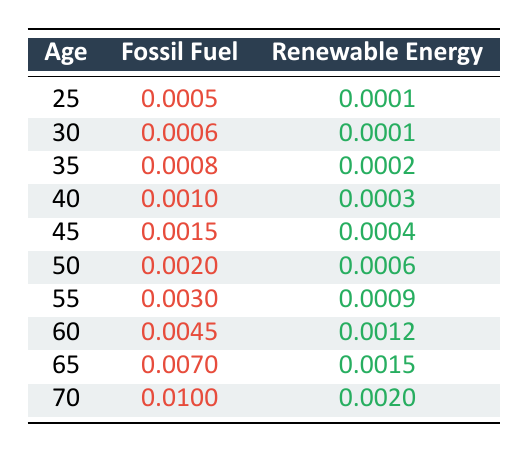What is the Fossil Fuel Mortality Rate for employees aged 50? The table shows that the Fossil Fuel Mortality Rate for employees aged 50 is listed as 0.0020.
Answer: 0.0020 What is the Renewable Energy Mortality Rate for employees aged 40? According to the table, the Renewable Energy Mortality Rate for employees aged 40 is 0.0003.
Answer: 0.0003 At which age is the Fossil Fuel Mortality Rate highest? The highest Fossil Fuel Mortality Rate in the table occurs at age 70, where it is 0.0100.
Answer: Age 70 Is the Renewable Energy Mortality Rate ever greater than the Fossil Fuel Mortality Rate? Reviewing the data, the Renewable Energy Mortality Rate is always lower than the Fossil Fuel Mortality Rate for all ages listed.
Answer: No What is the difference in Mortality Rates between fossil fuel and renewable energy employees at age 60? For age 60, the Fossil Fuel Mortality Rate is 0.0045 and the Renewable Energy Mortality Rate is 0.0012. The difference is calculated by subtracting the Renewable Energy rate from the Fossil Fuel rate: 0.0045 - 0.0012 = 0.0033.
Answer: 0.0033 What is the average Fossil Fuel Mortality Rate across all ages listed? First, sum the Fossil Fuel Mortality Rates: 0.0005 + 0.0006 + 0.0008 + 0.0010 + 0.0015 + 0.0020 + 0.0030 + 0.0045 + 0.0070 + 0.0100 = 0.0311. There are 10 age groups, thus the average is 0.0311 / 10 = 0.00311.
Answer: 0.00311 What are the two age groups where the difference in Mortality Rates for fossil fuel and renewable energy employees is minimum? The smallest difference occurs between ages 25 and 30, where the differences are 0.0004 (0.0005 - 0.0001) and 0.0005 (0.0006 - 0.0001), respectively. Thus, the two groups are age 25 and age 30.
Answer: Age 25 and age 30 At what age does the Renewable Energy Mortality Rate begin to increase? Analyzing the table, the Renewable Energy Mortality Rate increases starting from age 55 (0.0009), compared to age 50 (0.0006).
Answer: Age 55 